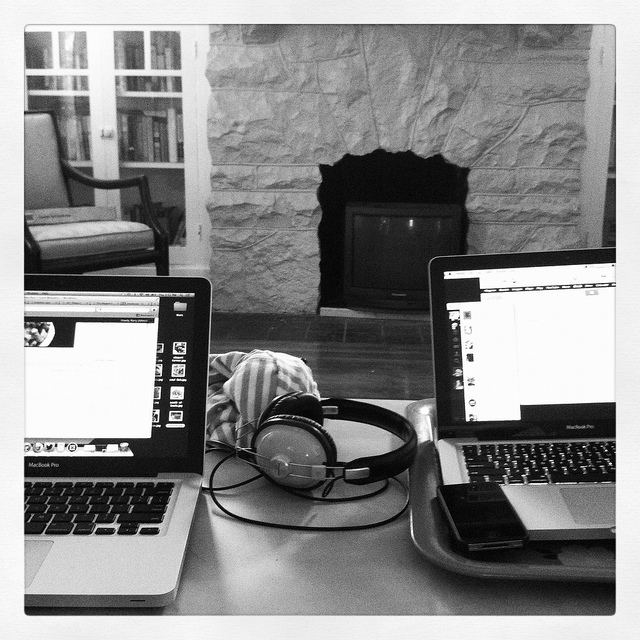<image>Where is the phone? It is unclear where the phone is located. It could possibly be on the right laptop, on the computer, or on the table. Where is the phone? The phone is either on the right laptop or on the computer. 